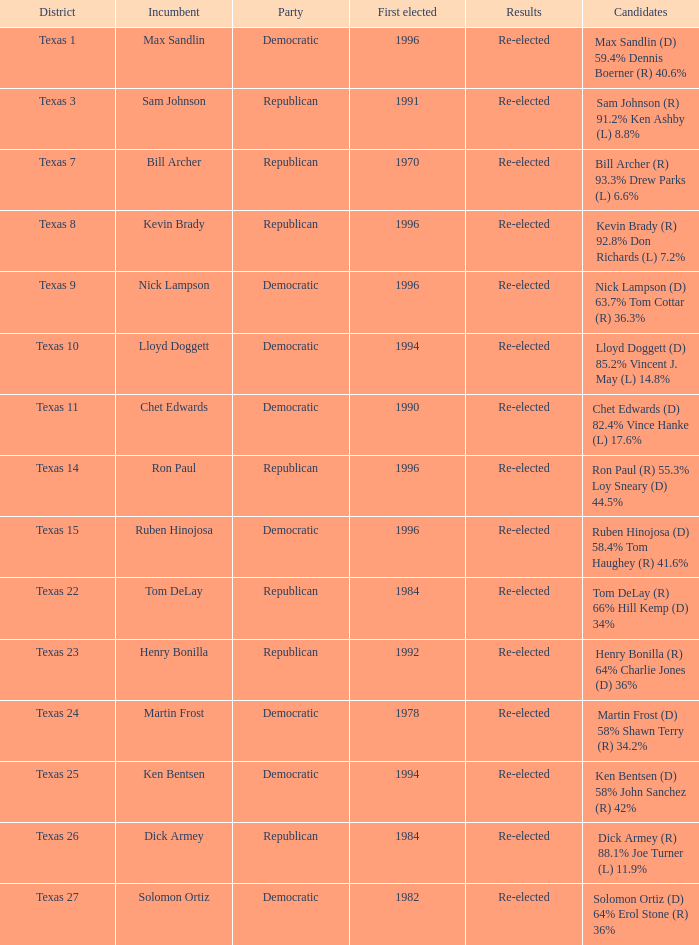How many times did ruben hinojosa, the incumbent, win elections? 1.0. 